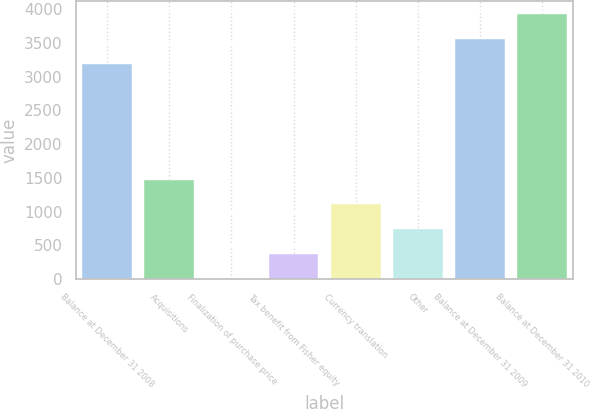Convert chart. <chart><loc_0><loc_0><loc_500><loc_500><bar_chart><fcel>Balance at December 31 2008<fcel>Acquisitions<fcel>Finalization of purchase price<fcel>Tax benefit from Fisher equity<fcel>Currency translation<fcel>Other<fcel>Balance at December 31 2009<fcel>Balance at December 31 2010<nl><fcel>3186.4<fcel>1473.2<fcel>0.6<fcel>368.75<fcel>1105.05<fcel>736.9<fcel>3554.55<fcel>3922.7<nl></chart> 